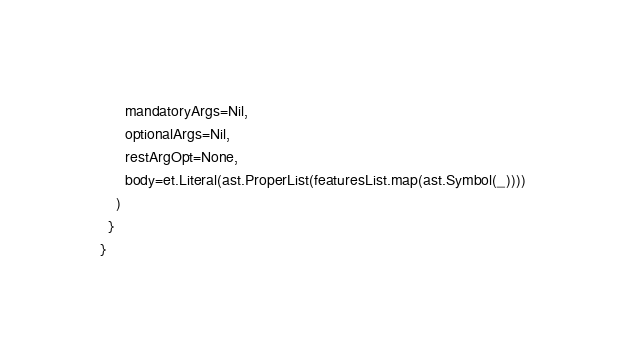<code> <loc_0><loc_0><loc_500><loc_500><_Scala_>      mandatoryArgs=Nil,
      optionalArgs=Nil,
      restArgOpt=None,
      body=et.Literal(ast.ProperList(featuresList.map(ast.Symbol(_))))
    )
  }
}
</code> 